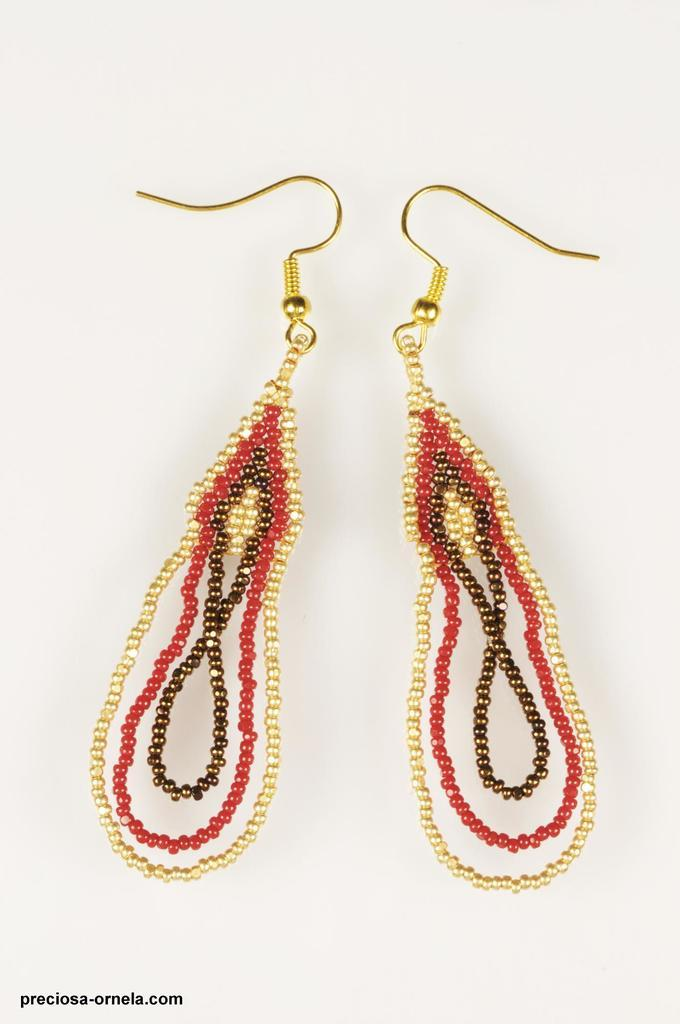What type of accessory is present in the image? There are earrings in the image. What colors are the earrings in the image? The earrings are in gold, brown, and red colors. What type of muscle can be seen flexing in the image? There is no muscle present in the image; it features earrings in gold, brown, and red colors. 